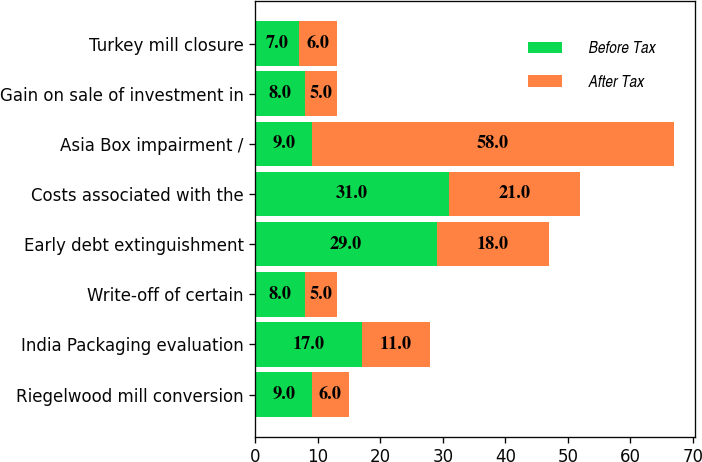<chart> <loc_0><loc_0><loc_500><loc_500><stacked_bar_chart><ecel><fcel>Riegelwood mill conversion<fcel>India Packaging evaluation<fcel>Write-off of certain<fcel>Early debt extinguishment<fcel>Costs associated with the<fcel>Asia Box impairment /<fcel>Gain on sale of investment in<fcel>Turkey mill closure<nl><fcel>Before Tax<fcel>9<fcel>17<fcel>8<fcel>29<fcel>31<fcel>9<fcel>8<fcel>7<nl><fcel>After Tax<fcel>6<fcel>11<fcel>5<fcel>18<fcel>21<fcel>58<fcel>5<fcel>6<nl></chart> 